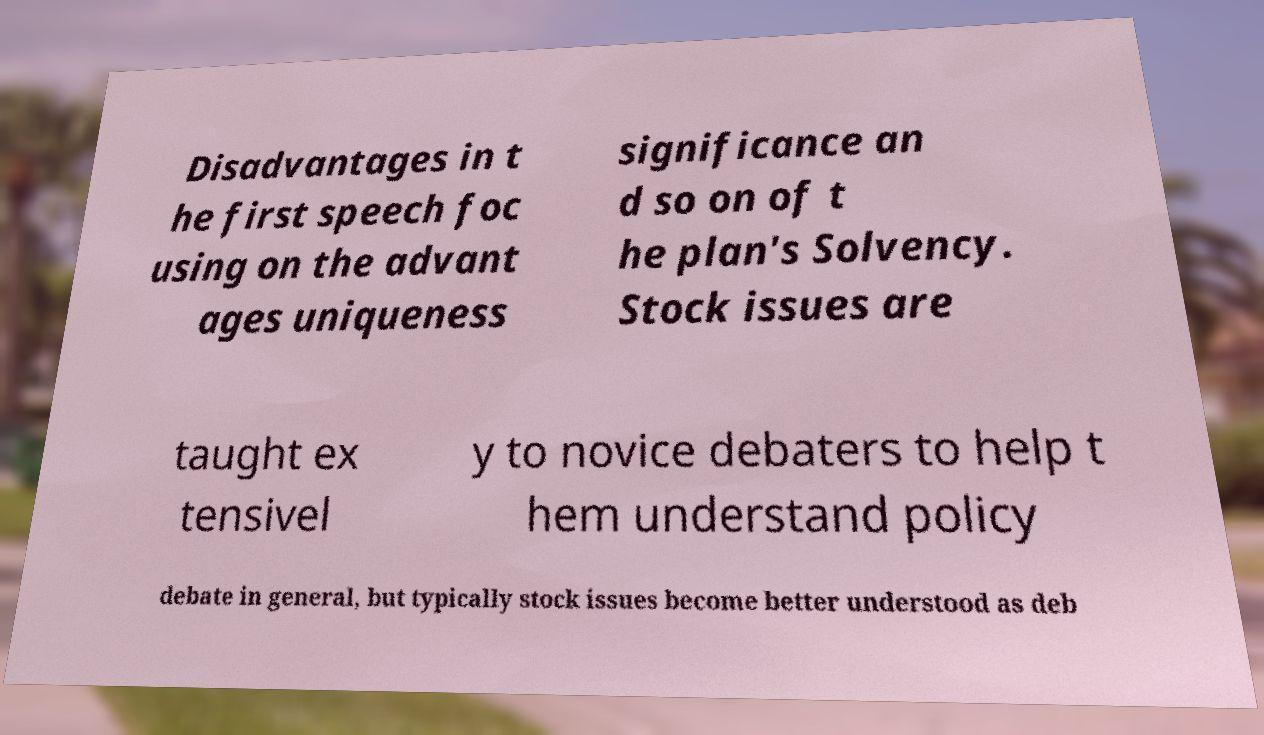For documentation purposes, I need the text within this image transcribed. Could you provide that? Disadvantages in t he first speech foc using on the advant ages uniqueness significance an d so on of t he plan's Solvency. Stock issues are taught ex tensivel y to novice debaters to help t hem understand policy debate in general, but typically stock issues become better understood as deb 